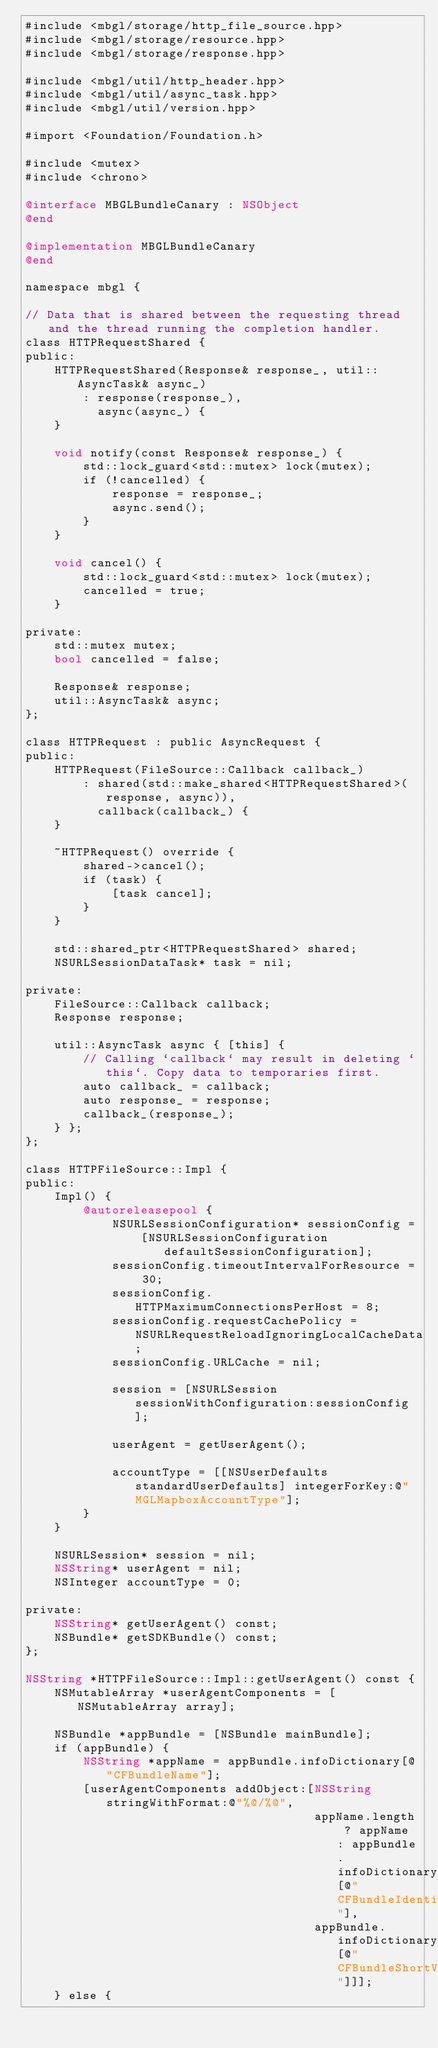Convert code to text. <code><loc_0><loc_0><loc_500><loc_500><_ObjectiveC_>#include <mbgl/storage/http_file_source.hpp>
#include <mbgl/storage/resource.hpp>
#include <mbgl/storage/response.hpp>

#include <mbgl/util/http_header.hpp>
#include <mbgl/util/async_task.hpp>
#include <mbgl/util/version.hpp>

#import <Foundation/Foundation.h>

#include <mutex>
#include <chrono>

@interface MBGLBundleCanary : NSObject
@end

@implementation MBGLBundleCanary
@end

namespace mbgl {

// Data that is shared between the requesting thread and the thread running the completion handler.
class HTTPRequestShared {
public:
    HTTPRequestShared(Response& response_, util::AsyncTask& async_)
        : response(response_),
          async(async_) {
    }

    void notify(const Response& response_) {
        std::lock_guard<std::mutex> lock(mutex);
        if (!cancelled) {
            response = response_;
            async.send();
        }
    }

    void cancel() {
        std::lock_guard<std::mutex> lock(mutex);
        cancelled = true;
    }

private:
    std::mutex mutex;
    bool cancelled = false;

    Response& response;
    util::AsyncTask& async;
};

class HTTPRequest : public AsyncRequest {
public:
    HTTPRequest(FileSource::Callback callback_)
        : shared(std::make_shared<HTTPRequestShared>(response, async)),
          callback(callback_) {
    }

    ~HTTPRequest() override {
        shared->cancel();
        if (task) {
            [task cancel];
        }
    }

    std::shared_ptr<HTTPRequestShared> shared;
    NSURLSessionDataTask* task = nil;

private:
    FileSource::Callback callback;
    Response response;

    util::AsyncTask async { [this] {
        // Calling `callback` may result in deleting `this`. Copy data to temporaries first.
        auto callback_ = callback;
        auto response_ = response;
        callback_(response_);
    } };
};

class HTTPFileSource::Impl {
public:
    Impl() {
        @autoreleasepool {
            NSURLSessionConfiguration* sessionConfig =
                [NSURLSessionConfiguration defaultSessionConfiguration];
            sessionConfig.timeoutIntervalForResource = 30;
            sessionConfig.HTTPMaximumConnectionsPerHost = 8;
            sessionConfig.requestCachePolicy = NSURLRequestReloadIgnoringLocalCacheData;
            sessionConfig.URLCache = nil;

            session = [NSURLSession sessionWithConfiguration:sessionConfig];

            userAgent = getUserAgent();

            accountType = [[NSUserDefaults standardUserDefaults] integerForKey:@"MGLMapboxAccountType"];
        }
    }

    NSURLSession* session = nil;
    NSString* userAgent = nil;
    NSInteger accountType = 0;

private:
    NSString* getUserAgent() const;
    NSBundle* getSDKBundle() const;
};

NSString *HTTPFileSource::Impl::getUserAgent() const {
    NSMutableArray *userAgentComponents = [NSMutableArray array];

    NSBundle *appBundle = [NSBundle mainBundle];
    if (appBundle) {
        NSString *appName = appBundle.infoDictionary[@"CFBundleName"];
        [userAgentComponents addObject:[NSString stringWithFormat:@"%@/%@",
                                        appName.length ? appName : appBundle.infoDictionary[@"CFBundleIdentifier"],
                                        appBundle.infoDictionary[@"CFBundleShortVersionString"]]];
    } else {</code> 